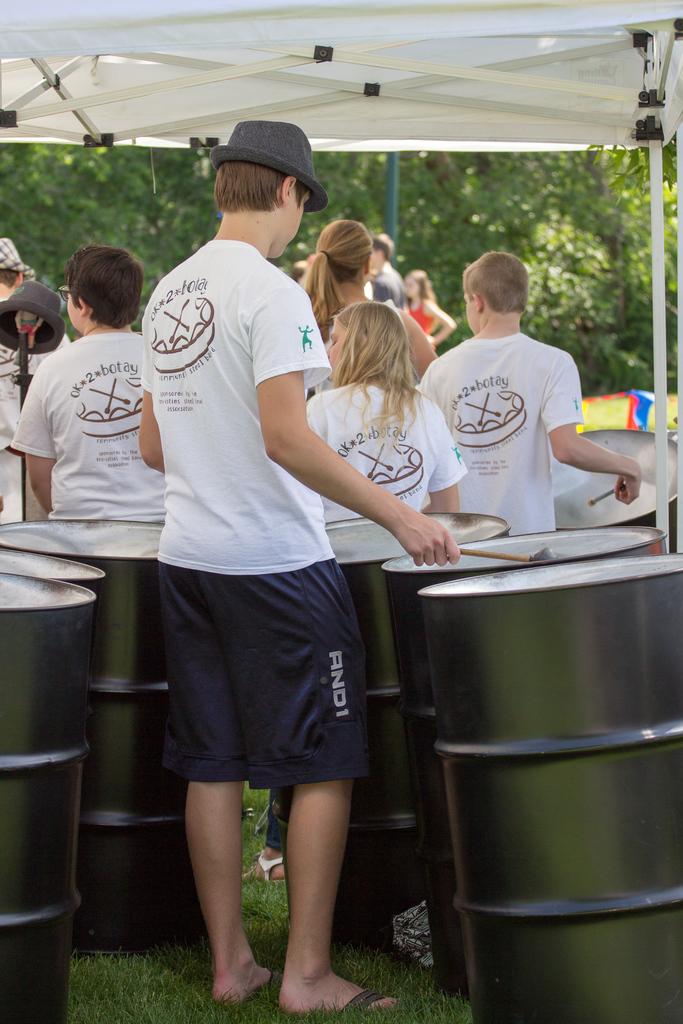What is written on the back to the shirts above the drum?
Make the answer very short. Ok*2*botay. 